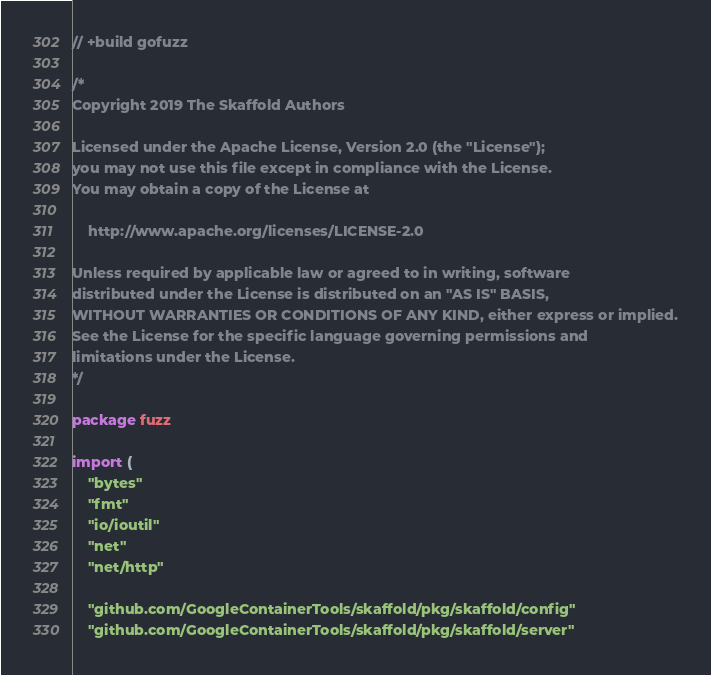<code> <loc_0><loc_0><loc_500><loc_500><_Go_>// +build gofuzz

/*
Copyright 2019 The Skaffold Authors

Licensed under the Apache License, Version 2.0 (the "License");
you may not use this file except in compliance with the License.
You may obtain a copy of the License at

    http://www.apache.org/licenses/LICENSE-2.0

Unless required by applicable law or agreed to in writing, software
distributed under the License is distributed on an "AS IS" BASIS,
WITHOUT WARRANTIES OR CONDITIONS OF ANY KIND, either express or implied.
See the License for the specific language governing permissions and
limitations under the License.
*/

package fuzz

import (
	"bytes"
	"fmt"
	"io/ioutil"
	"net"
	"net/http"

	"github.com/GoogleContainerTools/skaffold/pkg/skaffold/config"
	"github.com/GoogleContainerTools/skaffold/pkg/skaffold/server"</code> 